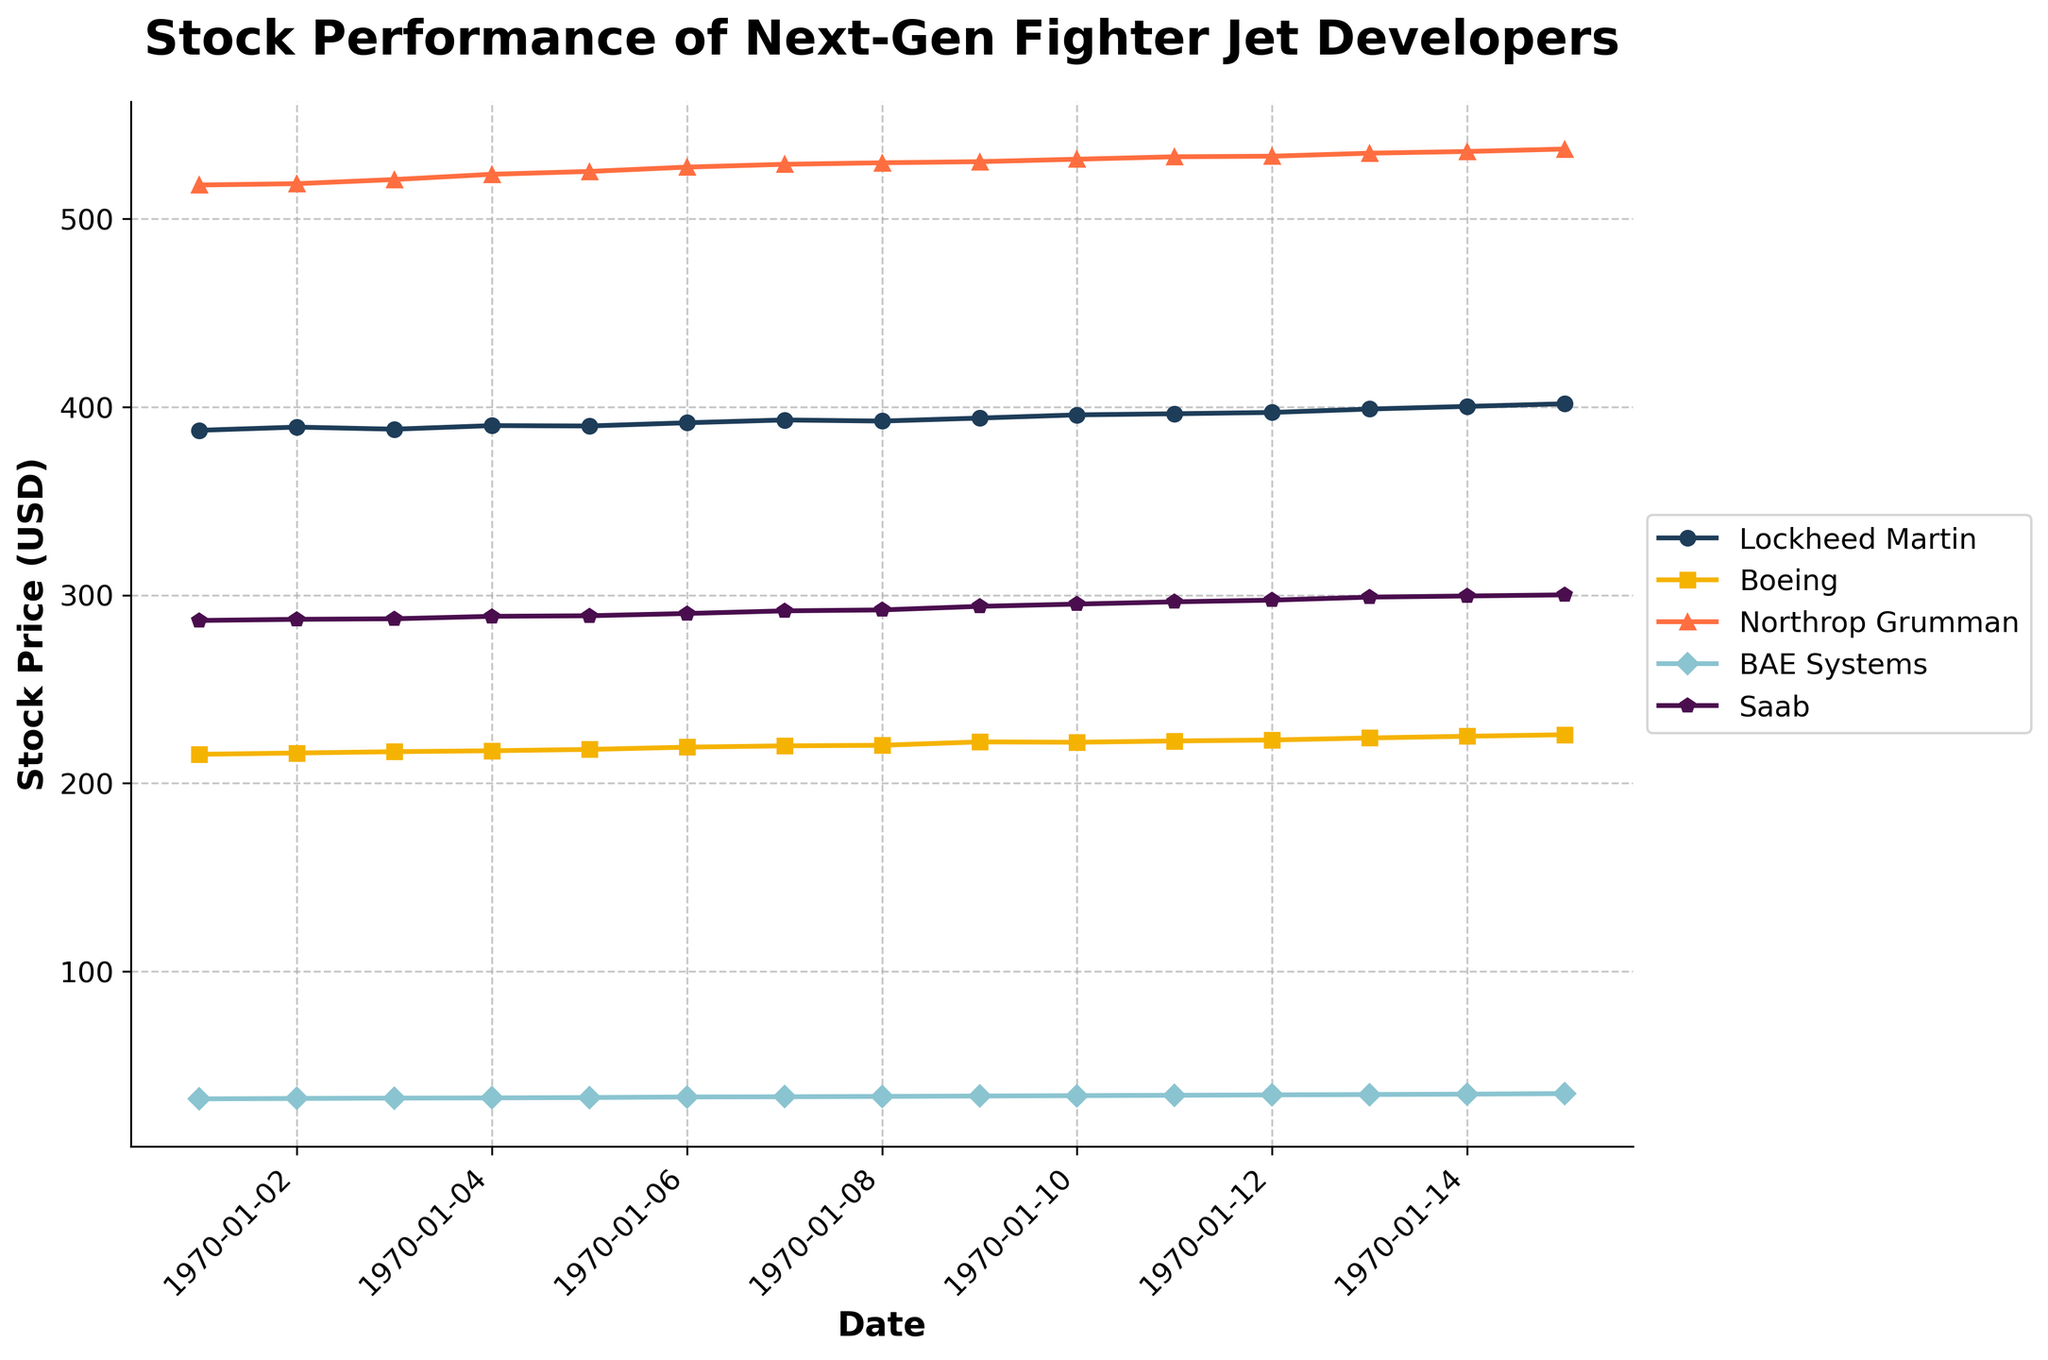What is the title of the figure? The title is typically located at the top of a plot and provides a summary of what the figure is about.
Answer: Stock Performance of Next-Gen Fighter Jet Developers How many companies are depicted in the figure? Count the number of different lines or entries in the legend.
Answer: Five Which company has the highest stock price on January 15, 2023? Look at the data points for January 15, 2023, and identify the highest value.
Answer: Northrop Grumman Which company's stock price shows the greatest overall increase from January 1, 2023, to January 15, 2023? Calculate the difference between the stock prices on January 1 and January 15 for each company, and compare them.
Answer: Lockheed Martin What are the marker styles used in the plot? Refer to the legend or the actual lines in the plot to identify the different markers used for each company.
Answer: Circle, square, triangle, diamond, and pentagon On which dates do Boeing and Saab have their highest stock prices within the given time frame? Examine the stock price trends for Boeing and Saab, identifying the peak values and corresponding dates.
Answer: January 13 for Boeing, January 15 for Saab What is the average stock price of BAE Systems over the given dates? Sum the stock prices of BAE Systems across all dates and divide by the number of dates.
Answer: 33.833 How does the stock price of Lockheed Martin on January 10 compare to its price on January 5? Subtract the stock price of January 5 from that of January 10 to determine if it has increased or decreased.
Answer: Increased by 5.9 Between Northrop Grumman and BAE Systems, which company shows a more steady increase in stock price? Observe the trend lines for both companies to see which one has a more gradual and consistent slope upwards.
Answer: Northrop Grumman What is the difference in stock price between the highest and lowest values for Boeing during the given period? Identify the highest and lowest stock prices for Boeing and calculate the difference.
Answer: 8.7 